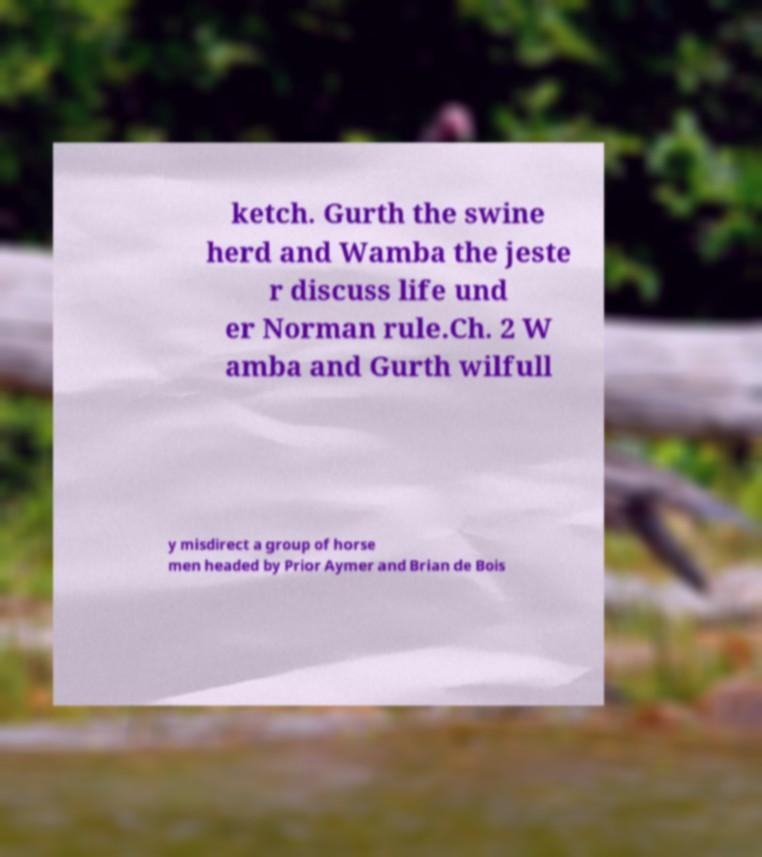Can you accurately transcribe the text from the provided image for me? ketch. Gurth the swine herd and Wamba the jeste r discuss life und er Norman rule.Ch. 2 W amba and Gurth wilfull y misdirect a group of horse men headed by Prior Aymer and Brian de Bois 